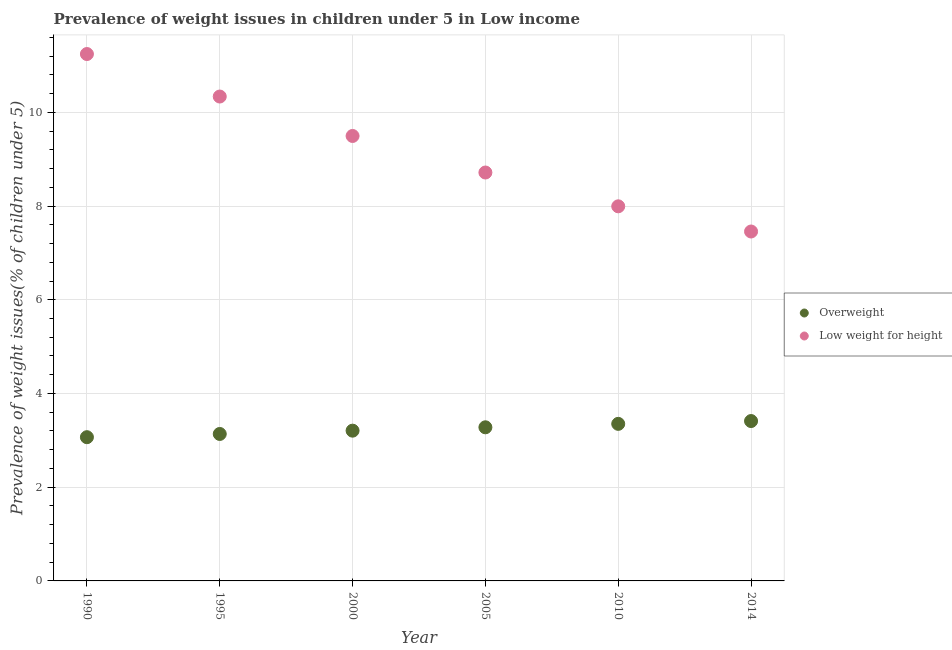Is the number of dotlines equal to the number of legend labels?
Your answer should be very brief. Yes. What is the percentage of overweight children in 2005?
Provide a short and direct response. 3.28. Across all years, what is the maximum percentage of underweight children?
Your answer should be very brief. 11.24. Across all years, what is the minimum percentage of overweight children?
Make the answer very short. 3.07. In which year was the percentage of overweight children maximum?
Your response must be concise. 2014. In which year was the percentage of underweight children minimum?
Provide a short and direct response. 2014. What is the total percentage of overweight children in the graph?
Offer a terse response. 19.45. What is the difference between the percentage of underweight children in 1995 and that in 2014?
Offer a terse response. 2.88. What is the difference between the percentage of underweight children in 2000 and the percentage of overweight children in 2005?
Your answer should be compact. 6.22. What is the average percentage of overweight children per year?
Keep it short and to the point. 3.24. In the year 1995, what is the difference between the percentage of overweight children and percentage of underweight children?
Offer a terse response. -7.2. What is the ratio of the percentage of underweight children in 1995 to that in 2005?
Ensure brevity in your answer.  1.19. What is the difference between the highest and the second highest percentage of overweight children?
Your answer should be compact. 0.06. What is the difference between the highest and the lowest percentage of overweight children?
Make the answer very short. 0.34. In how many years, is the percentage of overweight children greater than the average percentage of overweight children taken over all years?
Ensure brevity in your answer.  3. Does the percentage of underweight children monotonically increase over the years?
Make the answer very short. No. Is the percentage of overweight children strictly less than the percentage of underweight children over the years?
Provide a short and direct response. Yes. How many dotlines are there?
Give a very brief answer. 2. What is the difference between two consecutive major ticks on the Y-axis?
Your answer should be very brief. 2. Does the graph contain any zero values?
Provide a succinct answer. No. Does the graph contain grids?
Keep it short and to the point. Yes. Where does the legend appear in the graph?
Offer a terse response. Center right. What is the title of the graph?
Provide a short and direct response. Prevalence of weight issues in children under 5 in Low income. What is the label or title of the Y-axis?
Your answer should be very brief. Prevalence of weight issues(% of children under 5). What is the Prevalence of weight issues(% of children under 5) of Overweight in 1990?
Your answer should be very brief. 3.07. What is the Prevalence of weight issues(% of children under 5) in Low weight for height in 1990?
Ensure brevity in your answer.  11.24. What is the Prevalence of weight issues(% of children under 5) in Overweight in 1995?
Ensure brevity in your answer.  3.14. What is the Prevalence of weight issues(% of children under 5) of Low weight for height in 1995?
Your answer should be very brief. 10.34. What is the Prevalence of weight issues(% of children under 5) of Overweight in 2000?
Make the answer very short. 3.21. What is the Prevalence of weight issues(% of children under 5) of Low weight for height in 2000?
Provide a succinct answer. 9.5. What is the Prevalence of weight issues(% of children under 5) in Overweight in 2005?
Give a very brief answer. 3.28. What is the Prevalence of weight issues(% of children under 5) of Low weight for height in 2005?
Your answer should be compact. 8.72. What is the Prevalence of weight issues(% of children under 5) in Overweight in 2010?
Offer a very short reply. 3.35. What is the Prevalence of weight issues(% of children under 5) of Low weight for height in 2010?
Keep it short and to the point. 7.99. What is the Prevalence of weight issues(% of children under 5) of Overweight in 2014?
Your answer should be compact. 3.41. What is the Prevalence of weight issues(% of children under 5) of Low weight for height in 2014?
Provide a succinct answer. 7.46. Across all years, what is the maximum Prevalence of weight issues(% of children under 5) of Overweight?
Your answer should be compact. 3.41. Across all years, what is the maximum Prevalence of weight issues(% of children under 5) of Low weight for height?
Ensure brevity in your answer.  11.24. Across all years, what is the minimum Prevalence of weight issues(% of children under 5) in Overweight?
Your answer should be very brief. 3.07. Across all years, what is the minimum Prevalence of weight issues(% of children under 5) in Low weight for height?
Provide a short and direct response. 7.46. What is the total Prevalence of weight issues(% of children under 5) in Overweight in the graph?
Offer a very short reply. 19.45. What is the total Prevalence of weight issues(% of children under 5) in Low weight for height in the graph?
Keep it short and to the point. 55.24. What is the difference between the Prevalence of weight issues(% of children under 5) in Overweight in 1990 and that in 1995?
Keep it short and to the point. -0.07. What is the difference between the Prevalence of weight issues(% of children under 5) of Low weight for height in 1990 and that in 1995?
Your answer should be compact. 0.91. What is the difference between the Prevalence of weight issues(% of children under 5) of Overweight in 1990 and that in 2000?
Your answer should be very brief. -0.14. What is the difference between the Prevalence of weight issues(% of children under 5) of Low weight for height in 1990 and that in 2000?
Provide a short and direct response. 1.75. What is the difference between the Prevalence of weight issues(% of children under 5) of Overweight in 1990 and that in 2005?
Make the answer very short. -0.21. What is the difference between the Prevalence of weight issues(% of children under 5) of Low weight for height in 1990 and that in 2005?
Make the answer very short. 2.53. What is the difference between the Prevalence of weight issues(% of children under 5) in Overweight in 1990 and that in 2010?
Your answer should be compact. -0.28. What is the difference between the Prevalence of weight issues(% of children under 5) in Low weight for height in 1990 and that in 2010?
Ensure brevity in your answer.  3.25. What is the difference between the Prevalence of weight issues(% of children under 5) in Overweight in 1990 and that in 2014?
Provide a succinct answer. -0.34. What is the difference between the Prevalence of weight issues(% of children under 5) in Low weight for height in 1990 and that in 2014?
Offer a terse response. 3.79. What is the difference between the Prevalence of weight issues(% of children under 5) of Overweight in 1995 and that in 2000?
Provide a short and direct response. -0.07. What is the difference between the Prevalence of weight issues(% of children under 5) of Low weight for height in 1995 and that in 2000?
Provide a succinct answer. 0.84. What is the difference between the Prevalence of weight issues(% of children under 5) of Overweight in 1995 and that in 2005?
Provide a succinct answer. -0.14. What is the difference between the Prevalence of weight issues(% of children under 5) in Low weight for height in 1995 and that in 2005?
Keep it short and to the point. 1.62. What is the difference between the Prevalence of weight issues(% of children under 5) of Overweight in 1995 and that in 2010?
Provide a succinct answer. -0.22. What is the difference between the Prevalence of weight issues(% of children under 5) in Low weight for height in 1995 and that in 2010?
Your answer should be very brief. 2.34. What is the difference between the Prevalence of weight issues(% of children under 5) in Overweight in 1995 and that in 2014?
Keep it short and to the point. -0.28. What is the difference between the Prevalence of weight issues(% of children under 5) in Low weight for height in 1995 and that in 2014?
Provide a succinct answer. 2.88. What is the difference between the Prevalence of weight issues(% of children under 5) in Overweight in 2000 and that in 2005?
Provide a short and direct response. -0.07. What is the difference between the Prevalence of weight issues(% of children under 5) in Low weight for height in 2000 and that in 2005?
Ensure brevity in your answer.  0.78. What is the difference between the Prevalence of weight issues(% of children under 5) in Overweight in 2000 and that in 2010?
Offer a very short reply. -0.15. What is the difference between the Prevalence of weight issues(% of children under 5) in Low weight for height in 2000 and that in 2010?
Provide a short and direct response. 1.5. What is the difference between the Prevalence of weight issues(% of children under 5) in Overweight in 2000 and that in 2014?
Keep it short and to the point. -0.21. What is the difference between the Prevalence of weight issues(% of children under 5) of Low weight for height in 2000 and that in 2014?
Ensure brevity in your answer.  2.04. What is the difference between the Prevalence of weight issues(% of children under 5) in Overweight in 2005 and that in 2010?
Give a very brief answer. -0.07. What is the difference between the Prevalence of weight issues(% of children under 5) in Low weight for height in 2005 and that in 2010?
Give a very brief answer. 0.72. What is the difference between the Prevalence of weight issues(% of children under 5) in Overweight in 2005 and that in 2014?
Provide a succinct answer. -0.13. What is the difference between the Prevalence of weight issues(% of children under 5) of Low weight for height in 2005 and that in 2014?
Offer a terse response. 1.26. What is the difference between the Prevalence of weight issues(% of children under 5) of Overweight in 2010 and that in 2014?
Offer a very short reply. -0.06. What is the difference between the Prevalence of weight issues(% of children under 5) of Low weight for height in 2010 and that in 2014?
Your answer should be very brief. 0.54. What is the difference between the Prevalence of weight issues(% of children under 5) in Overweight in 1990 and the Prevalence of weight issues(% of children under 5) in Low weight for height in 1995?
Your answer should be compact. -7.27. What is the difference between the Prevalence of weight issues(% of children under 5) of Overweight in 1990 and the Prevalence of weight issues(% of children under 5) of Low weight for height in 2000?
Your answer should be compact. -6.43. What is the difference between the Prevalence of weight issues(% of children under 5) of Overweight in 1990 and the Prevalence of weight issues(% of children under 5) of Low weight for height in 2005?
Offer a terse response. -5.65. What is the difference between the Prevalence of weight issues(% of children under 5) of Overweight in 1990 and the Prevalence of weight issues(% of children under 5) of Low weight for height in 2010?
Your response must be concise. -4.93. What is the difference between the Prevalence of weight issues(% of children under 5) of Overweight in 1990 and the Prevalence of weight issues(% of children under 5) of Low weight for height in 2014?
Your answer should be compact. -4.39. What is the difference between the Prevalence of weight issues(% of children under 5) in Overweight in 1995 and the Prevalence of weight issues(% of children under 5) in Low weight for height in 2000?
Provide a succinct answer. -6.36. What is the difference between the Prevalence of weight issues(% of children under 5) of Overweight in 1995 and the Prevalence of weight issues(% of children under 5) of Low weight for height in 2005?
Provide a short and direct response. -5.58. What is the difference between the Prevalence of weight issues(% of children under 5) in Overweight in 1995 and the Prevalence of weight issues(% of children under 5) in Low weight for height in 2010?
Provide a short and direct response. -4.86. What is the difference between the Prevalence of weight issues(% of children under 5) in Overweight in 1995 and the Prevalence of weight issues(% of children under 5) in Low weight for height in 2014?
Provide a short and direct response. -4.32. What is the difference between the Prevalence of weight issues(% of children under 5) of Overweight in 2000 and the Prevalence of weight issues(% of children under 5) of Low weight for height in 2005?
Give a very brief answer. -5.51. What is the difference between the Prevalence of weight issues(% of children under 5) of Overweight in 2000 and the Prevalence of weight issues(% of children under 5) of Low weight for height in 2010?
Your response must be concise. -4.79. What is the difference between the Prevalence of weight issues(% of children under 5) of Overweight in 2000 and the Prevalence of weight issues(% of children under 5) of Low weight for height in 2014?
Offer a terse response. -4.25. What is the difference between the Prevalence of weight issues(% of children under 5) of Overweight in 2005 and the Prevalence of weight issues(% of children under 5) of Low weight for height in 2010?
Your answer should be compact. -4.72. What is the difference between the Prevalence of weight issues(% of children under 5) of Overweight in 2005 and the Prevalence of weight issues(% of children under 5) of Low weight for height in 2014?
Ensure brevity in your answer.  -4.18. What is the difference between the Prevalence of weight issues(% of children under 5) in Overweight in 2010 and the Prevalence of weight issues(% of children under 5) in Low weight for height in 2014?
Your answer should be very brief. -4.11. What is the average Prevalence of weight issues(% of children under 5) in Overweight per year?
Keep it short and to the point. 3.24. What is the average Prevalence of weight issues(% of children under 5) of Low weight for height per year?
Offer a terse response. 9.21. In the year 1990, what is the difference between the Prevalence of weight issues(% of children under 5) in Overweight and Prevalence of weight issues(% of children under 5) in Low weight for height?
Make the answer very short. -8.18. In the year 1995, what is the difference between the Prevalence of weight issues(% of children under 5) in Overweight and Prevalence of weight issues(% of children under 5) in Low weight for height?
Your answer should be compact. -7.2. In the year 2000, what is the difference between the Prevalence of weight issues(% of children under 5) of Overweight and Prevalence of weight issues(% of children under 5) of Low weight for height?
Your answer should be very brief. -6.29. In the year 2005, what is the difference between the Prevalence of weight issues(% of children under 5) in Overweight and Prevalence of weight issues(% of children under 5) in Low weight for height?
Your answer should be compact. -5.44. In the year 2010, what is the difference between the Prevalence of weight issues(% of children under 5) of Overweight and Prevalence of weight issues(% of children under 5) of Low weight for height?
Offer a very short reply. -4.64. In the year 2014, what is the difference between the Prevalence of weight issues(% of children under 5) of Overweight and Prevalence of weight issues(% of children under 5) of Low weight for height?
Your answer should be compact. -4.05. What is the ratio of the Prevalence of weight issues(% of children under 5) of Overweight in 1990 to that in 1995?
Your response must be concise. 0.98. What is the ratio of the Prevalence of weight issues(% of children under 5) of Low weight for height in 1990 to that in 1995?
Provide a succinct answer. 1.09. What is the ratio of the Prevalence of weight issues(% of children under 5) in Overweight in 1990 to that in 2000?
Ensure brevity in your answer.  0.96. What is the ratio of the Prevalence of weight issues(% of children under 5) in Low weight for height in 1990 to that in 2000?
Your answer should be compact. 1.18. What is the ratio of the Prevalence of weight issues(% of children under 5) of Overweight in 1990 to that in 2005?
Make the answer very short. 0.94. What is the ratio of the Prevalence of weight issues(% of children under 5) in Low weight for height in 1990 to that in 2005?
Ensure brevity in your answer.  1.29. What is the ratio of the Prevalence of weight issues(% of children under 5) of Overweight in 1990 to that in 2010?
Your answer should be very brief. 0.92. What is the ratio of the Prevalence of weight issues(% of children under 5) in Low weight for height in 1990 to that in 2010?
Provide a short and direct response. 1.41. What is the ratio of the Prevalence of weight issues(% of children under 5) in Overweight in 1990 to that in 2014?
Ensure brevity in your answer.  0.9. What is the ratio of the Prevalence of weight issues(% of children under 5) of Low weight for height in 1990 to that in 2014?
Your response must be concise. 1.51. What is the ratio of the Prevalence of weight issues(% of children under 5) of Overweight in 1995 to that in 2000?
Ensure brevity in your answer.  0.98. What is the ratio of the Prevalence of weight issues(% of children under 5) of Low weight for height in 1995 to that in 2000?
Ensure brevity in your answer.  1.09. What is the ratio of the Prevalence of weight issues(% of children under 5) in Overweight in 1995 to that in 2005?
Give a very brief answer. 0.96. What is the ratio of the Prevalence of weight issues(% of children under 5) of Low weight for height in 1995 to that in 2005?
Ensure brevity in your answer.  1.19. What is the ratio of the Prevalence of weight issues(% of children under 5) of Overweight in 1995 to that in 2010?
Give a very brief answer. 0.94. What is the ratio of the Prevalence of weight issues(% of children under 5) in Low weight for height in 1995 to that in 2010?
Your response must be concise. 1.29. What is the ratio of the Prevalence of weight issues(% of children under 5) of Overweight in 1995 to that in 2014?
Your answer should be very brief. 0.92. What is the ratio of the Prevalence of weight issues(% of children under 5) of Low weight for height in 1995 to that in 2014?
Keep it short and to the point. 1.39. What is the ratio of the Prevalence of weight issues(% of children under 5) of Overweight in 2000 to that in 2005?
Give a very brief answer. 0.98. What is the ratio of the Prevalence of weight issues(% of children under 5) in Low weight for height in 2000 to that in 2005?
Your response must be concise. 1.09. What is the ratio of the Prevalence of weight issues(% of children under 5) in Overweight in 2000 to that in 2010?
Provide a short and direct response. 0.96. What is the ratio of the Prevalence of weight issues(% of children under 5) in Low weight for height in 2000 to that in 2010?
Make the answer very short. 1.19. What is the ratio of the Prevalence of weight issues(% of children under 5) of Overweight in 2000 to that in 2014?
Keep it short and to the point. 0.94. What is the ratio of the Prevalence of weight issues(% of children under 5) in Low weight for height in 2000 to that in 2014?
Ensure brevity in your answer.  1.27. What is the ratio of the Prevalence of weight issues(% of children under 5) in Overweight in 2005 to that in 2010?
Make the answer very short. 0.98. What is the ratio of the Prevalence of weight issues(% of children under 5) in Low weight for height in 2005 to that in 2010?
Your answer should be very brief. 1.09. What is the ratio of the Prevalence of weight issues(% of children under 5) of Overweight in 2005 to that in 2014?
Offer a very short reply. 0.96. What is the ratio of the Prevalence of weight issues(% of children under 5) in Low weight for height in 2005 to that in 2014?
Keep it short and to the point. 1.17. What is the ratio of the Prevalence of weight issues(% of children under 5) in Overweight in 2010 to that in 2014?
Your answer should be compact. 0.98. What is the ratio of the Prevalence of weight issues(% of children under 5) in Low weight for height in 2010 to that in 2014?
Your response must be concise. 1.07. What is the difference between the highest and the second highest Prevalence of weight issues(% of children under 5) in Overweight?
Give a very brief answer. 0.06. What is the difference between the highest and the second highest Prevalence of weight issues(% of children under 5) in Low weight for height?
Make the answer very short. 0.91. What is the difference between the highest and the lowest Prevalence of weight issues(% of children under 5) in Overweight?
Your response must be concise. 0.34. What is the difference between the highest and the lowest Prevalence of weight issues(% of children under 5) in Low weight for height?
Ensure brevity in your answer.  3.79. 